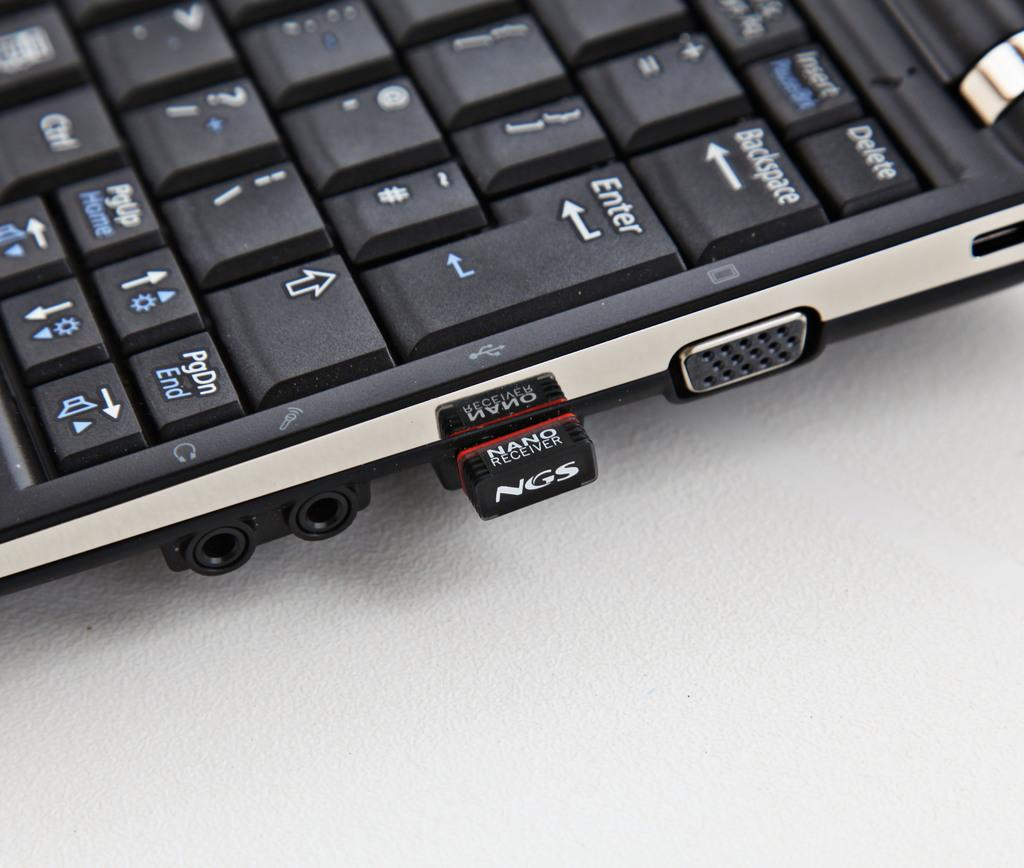<image>
Give a short and clear explanation of the subsequent image. A NGS brand nano receiver in the side of a laptop. 